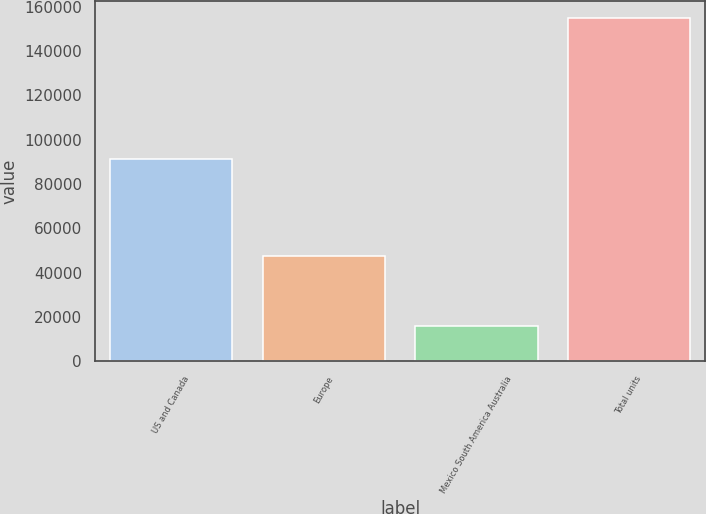Convert chart to OTSL. <chart><loc_0><loc_0><loc_500><loc_500><bar_chart><fcel>US and Canada<fcel>Europe<fcel>Mexico South America Australia<fcel>Total units<nl><fcel>91300<fcel>47400<fcel>16000<fcel>154700<nl></chart> 